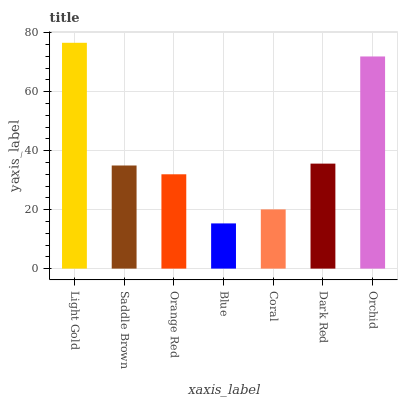Is Blue the minimum?
Answer yes or no. Yes. Is Light Gold the maximum?
Answer yes or no. Yes. Is Saddle Brown the minimum?
Answer yes or no. No. Is Saddle Brown the maximum?
Answer yes or no. No. Is Light Gold greater than Saddle Brown?
Answer yes or no. Yes. Is Saddle Brown less than Light Gold?
Answer yes or no. Yes. Is Saddle Brown greater than Light Gold?
Answer yes or no. No. Is Light Gold less than Saddle Brown?
Answer yes or no. No. Is Saddle Brown the high median?
Answer yes or no. Yes. Is Saddle Brown the low median?
Answer yes or no. Yes. Is Dark Red the high median?
Answer yes or no. No. Is Light Gold the low median?
Answer yes or no. No. 